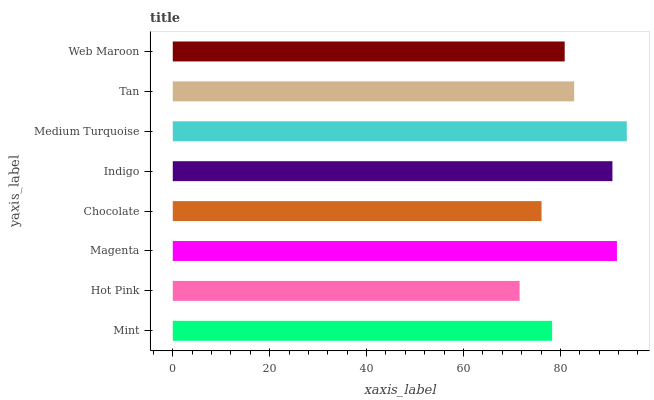Is Hot Pink the minimum?
Answer yes or no. Yes. Is Medium Turquoise the maximum?
Answer yes or no. Yes. Is Magenta the minimum?
Answer yes or no. No. Is Magenta the maximum?
Answer yes or no. No. Is Magenta greater than Hot Pink?
Answer yes or no. Yes. Is Hot Pink less than Magenta?
Answer yes or no. Yes. Is Hot Pink greater than Magenta?
Answer yes or no. No. Is Magenta less than Hot Pink?
Answer yes or no. No. Is Tan the high median?
Answer yes or no. Yes. Is Web Maroon the low median?
Answer yes or no. Yes. Is Indigo the high median?
Answer yes or no. No. Is Mint the low median?
Answer yes or no. No. 